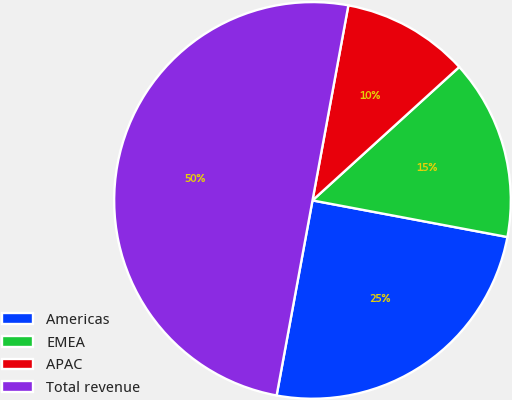Convert chart. <chart><loc_0><loc_0><loc_500><loc_500><pie_chart><fcel>Americas<fcel>EMEA<fcel>APAC<fcel>Total revenue<nl><fcel>24.94%<fcel>14.7%<fcel>10.36%<fcel>50.0%<nl></chart> 